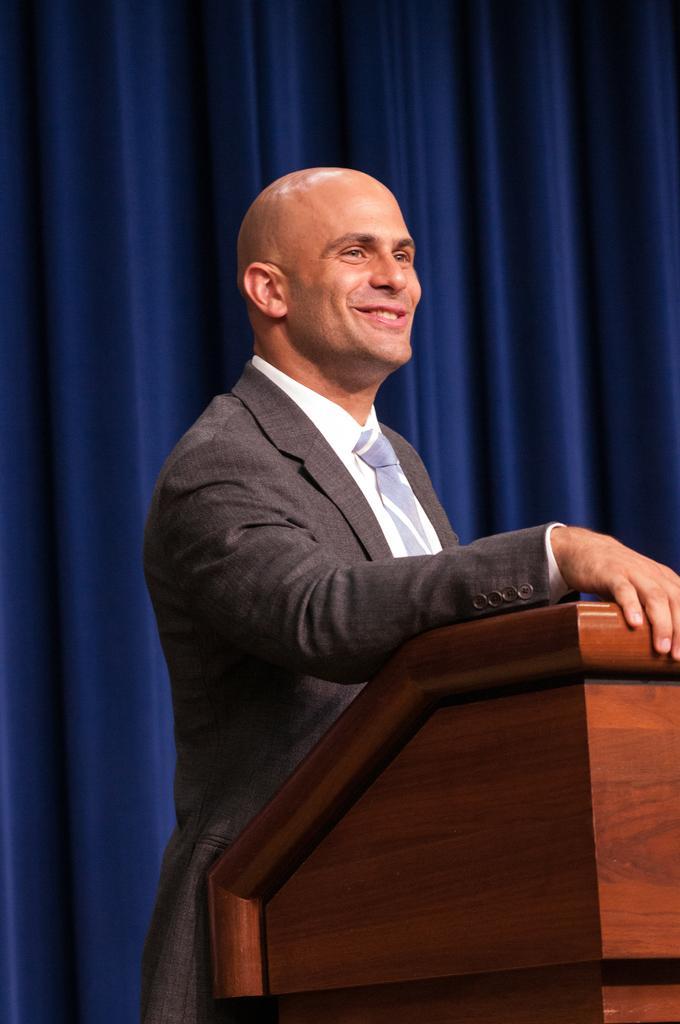Could you give a brief overview of what you see in this image? In the foreground of the picture there is a person standing near a podium. The person is wearing a grey suit. In the background there is a blue curtain. 